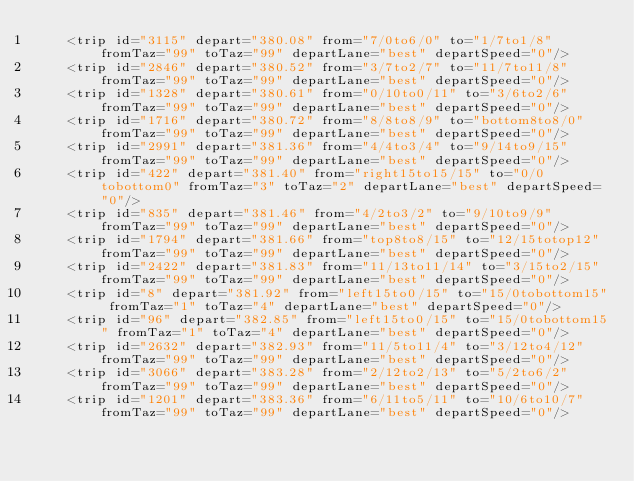Convert code to text. <code><loc_0><loc_0><loc_500><loc_500><_XML_>    <trip id="3115" depart="380.08" from="7/0to6/0" to="1/7to1/8" fromTaz="99" toTaz="99" departLane="best" departSpeed="0"/>
    <trip id="2846" depart="380.52" from="3/7to2/7" to="11/7to11/8" fromTaz="99" toTaz="99" departLane="best" departSpeed="0"/>
    <trip id="1328" depart="380.61" from="0/10to0/11" to="3/6to2/6" fromTaz="99" toTaz="99" departLane="best" departSpeed="0"/>
    <trip id="1716" depart="380.72" from="8/8to8/9" to="bottom8to8/0" fromTaz="99" toTaz="99" departLane="best" departSpeed="0"/>
    <trip id="2991" depart="381.36" from="4/4to3/4" to="9/14to9/15" fromTaz="99" toTaz="99" departLane="best" departSpeed="0"/>
    <trip id="422" depart="381.40" from="right15to15/15" to="0/0tobottom0" fromTaz="3" toTaz="2" departLane="best" departSpeed="0"/>
    <trip id="835" depart="381.46" from="4/2to3/2" to="9/10to9/9" fromTaz="99" toTaz="99" departLane="best" departSpeed="0"/>
    <trip id="1794" depart="381.66" from="top8to8/15" to="12/15totop12" fromTaz="99" toTaz="99" departLane="best" departSpeed="0"/>
    <trip id="2422" depart="381.83" from="11/13to11/14" to="3/15to2/15" fromTaz="99" toTaz="99" departLane="best" departSpeed="0"/>
    <trip id="8" depart="381.92" from="left15to0/15" to="15/0tobottom15" fromTaz="1" toTaz="4" departLane="best" departSpeed="0"/>
    <trip id="96" depart="382.85" from="left15to0/15" to="15/0tobottom15" fromTaz="1" toTaz="4" departLane="best" departSpeed="0"/>
    <trip id="2632" depart="382.93" from="11/5to11/4" to="3/12to4/12" fromTaz="99" toTaz="99" departLane="best" departSpeed="0"/>
    <trip id="3066" depart="383.28" from="2/12to2/13" to="5/2to6/2" fromTaz="99" toTaz="99" departLane="best" departSpeed="0"/>
    <trip id="1201" depart="383.36" from="6/11to5/11" to="10/6to10/7" fromTaz="99" toTaz="99" departLane="best" departSpeed="0"/></code> 